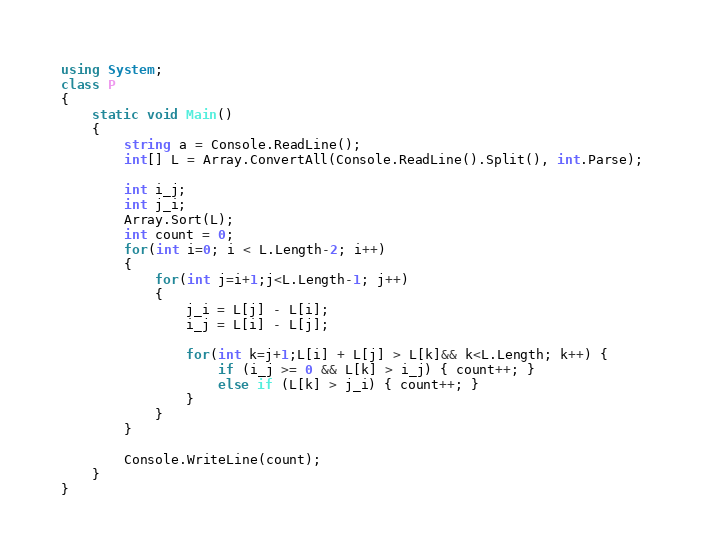Convert code to text. <code><loc_0><loc_0><loc_500><loc_500><_C#_>using System;
class P
{
    static void Main()
    {
        string a = Console.ReadLine();
        int[] L = Array.ConvertAll(Console.ReadLine().Split(), int.Parse);

        int i_j;
        int j_i;
        Array.Sort(L);
        int count = 0;
        for(int i=0; i < L.Length-2; i++)
        {
            for(int j=i+1;j<L.Length-1; j++)
            {
                j_i = L[j] - L[i];
                i_j = L[i] - L[j];

                for(int k=j+1;L[i] + L[j] > L[k]&& k<L.Length; k++) {
                    if (i_j >= 0 && L[k] > i_j) { count++; }
                    else if (L[k] > j_i) { count++; }
                }
            }
        }

        Console.WriteLine(count);
    }
}
</code> 